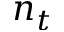<formula> <loc_0><loc_0><loc_500><loc_500>n _ { t }</formula> 